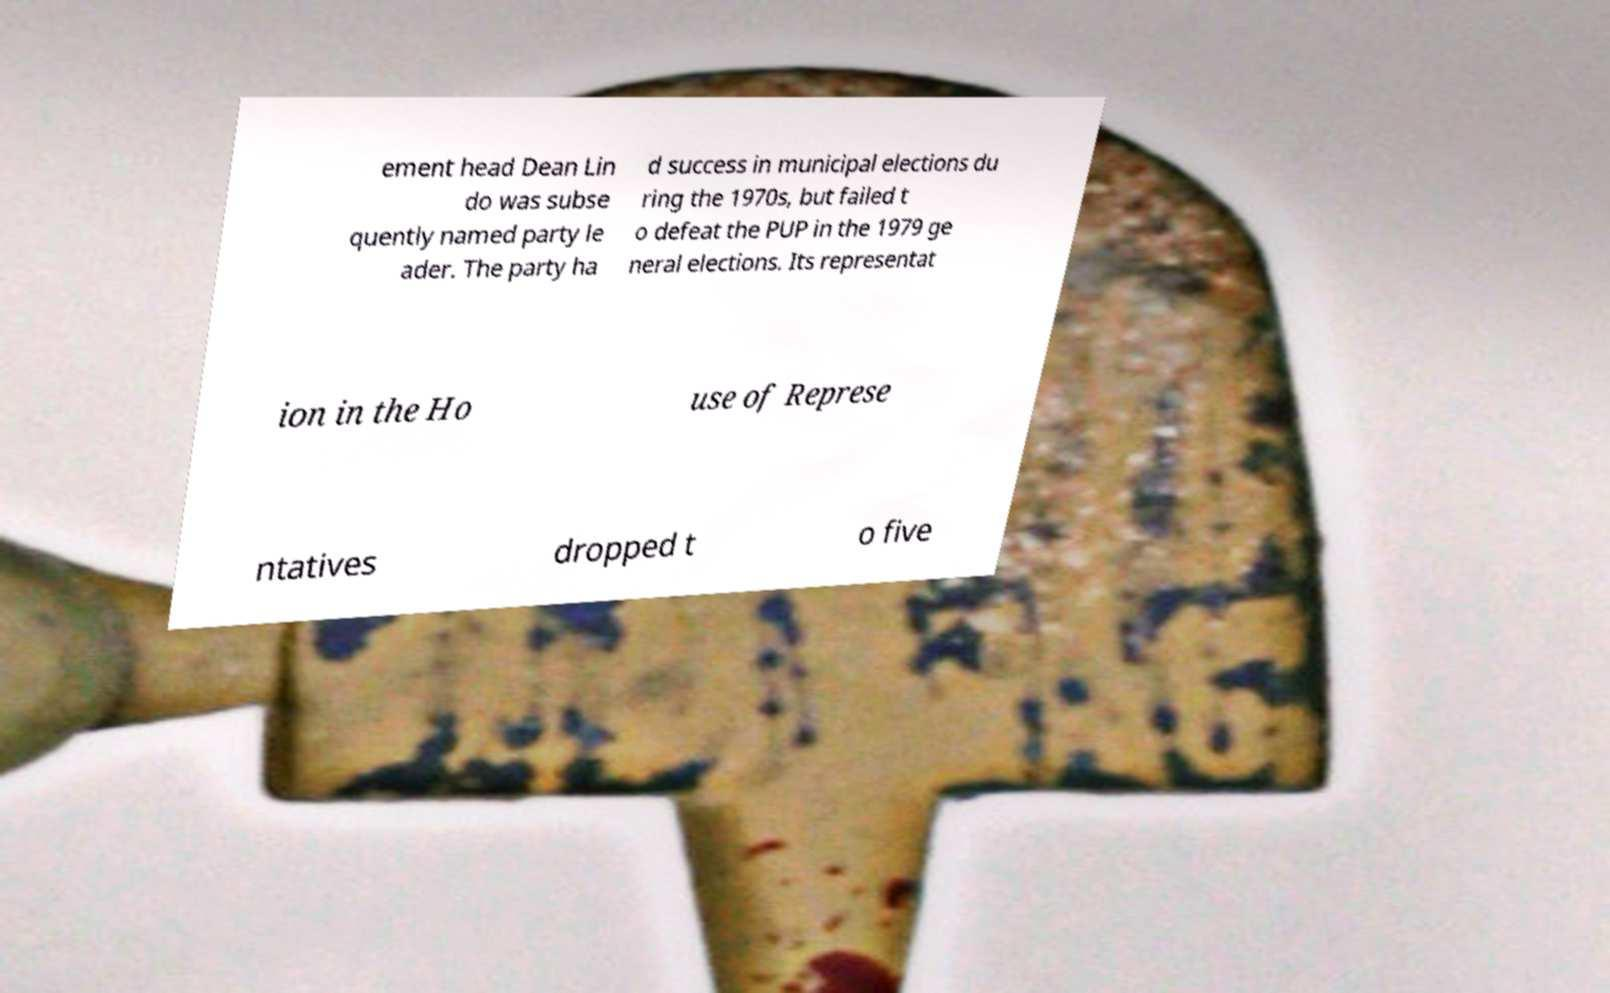Could you extract and type out the text from this image? ement head Dean Lin do was subse quently named party le ader. The party ha d success in municipal elections du ring the 1970s, but failed t o defeat the PUP in the 1979 ge neral elections. Its representat ion in the Ho use of Represe ntatives dropped t o five 